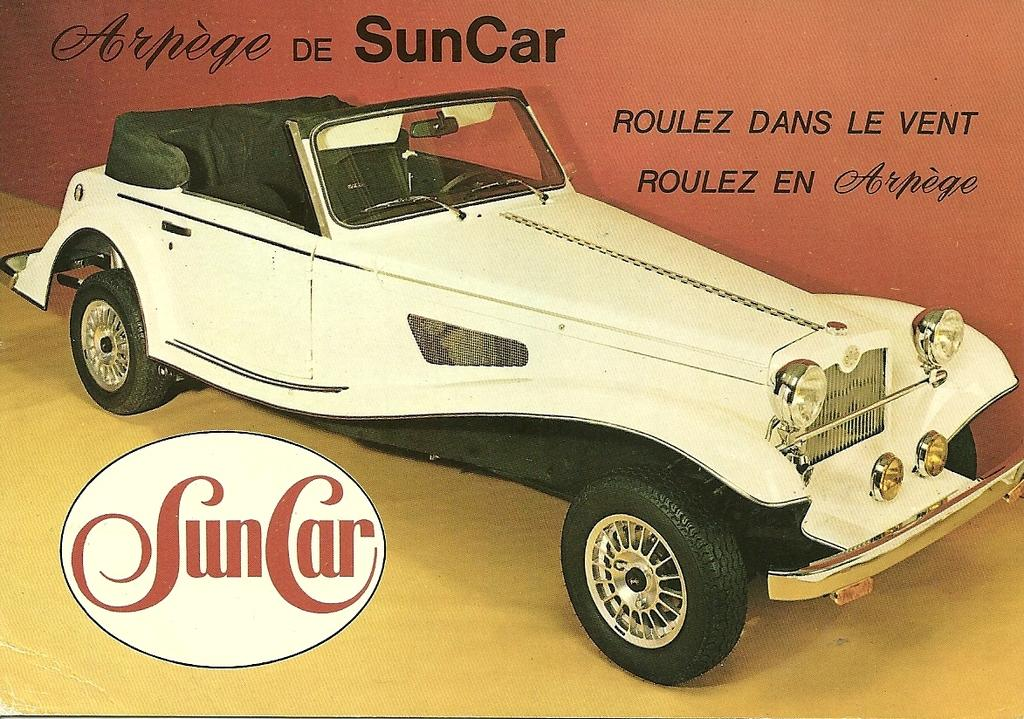What is depicted on the poster in the image? The poster features a white car. Are there any words on the poster? Yes, there are words written on the poster. What type of cork can be seen in the image? There is no cork present in the image. What religion is depicted on the poster? The poster does not depict any religion; it features a white car and words. 